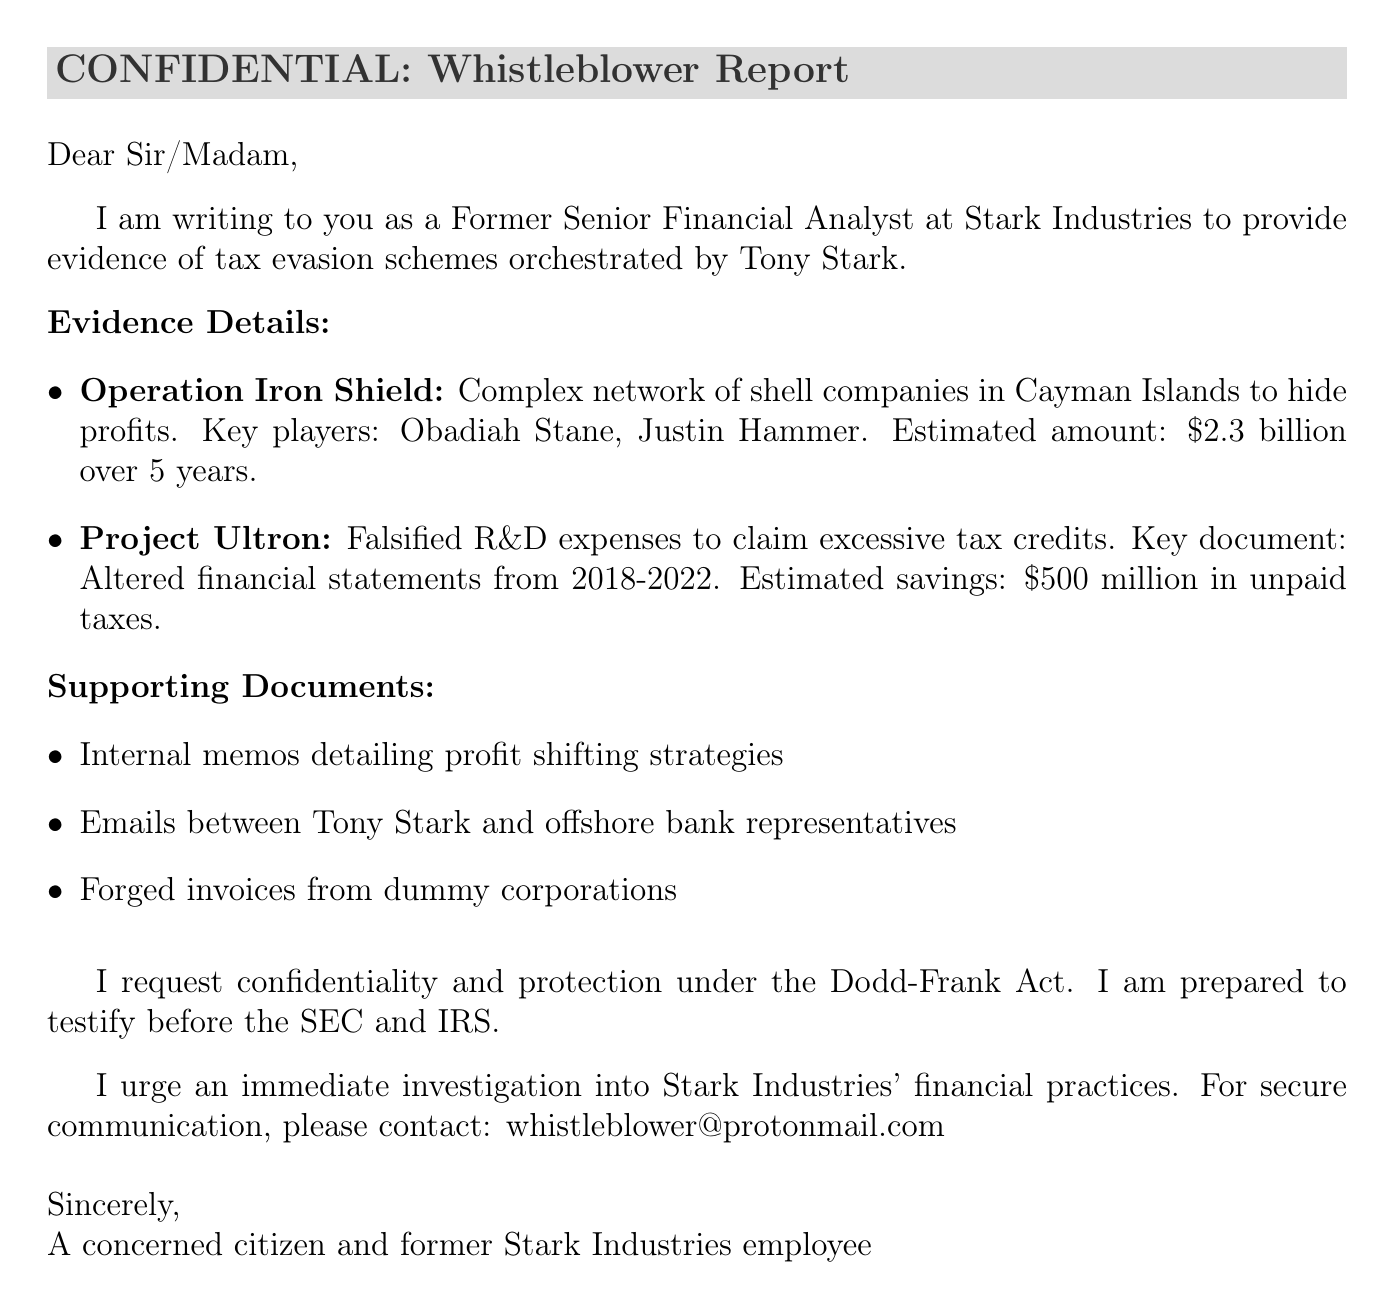What is the sender's title? The sender identifies as a Former Senior Financial Analyst at Stark Industries.
Answer: Former Senior Financial Analyst What is the estimated amount for Operation Iron Shield? The document states that the estimated amount for Operation Iron Shield is $2.3 billion over 5 years.
Answer: $2.3 billion over 5 years Who are the key players in Operation Iron Shield? The document lists Obadiah Stane and Justin Hammer as key players in Operation Iron Shield.
Answer: Obadiah Stane, Justin Hammer What is the estimated savings from Project Ultron? The estimated savings from Project Ultron, as mentioned in the document, is $500 million in unpaid taxes.
Answer: $500 million in unpaid taxes What protection does the whistleblower request? The whistleblower requests confidentiality and protection under the Dodd-Frank Act.
Answer: Dodd-Frank Act What type of evidence is included in the supporting documents? The supporting documents include internal memos, emails, and forged invoices.
Answer: Internal memos, emails, forged invoices How should one contact the whistleblower? The contact information provided for the whistleblower is a secure email address, whistleblower@protonmail.com.
Answer: whistleblower@protonmail.com What is the main call to action in the letter? The main call to action is to urge an immediate investigation into Stark Industries' financial practices.
Answer: Immediate investigation into Stark Industries' financial practices What kind of testimony is the whistleblower willing to provide? The whistleblower is prepared to testify before the SEC and IRS.
Answer: Testify before the SEC and IRS 